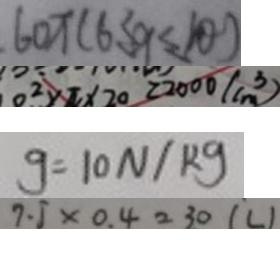<formula> <loc_0><loc_0><loc_500><loc_500>6 0 \pi ( 6 \leq 9 \leq 1 0 ) 
 0 ^ { 2 } \times \pi \times 2 0 = 2 0 0 0 ( c m ^ { 3 } ) 
 g = 1 0 N / k g 
 7 . 5 \times 0 . 4 = 3 0 ( L )</formula> 